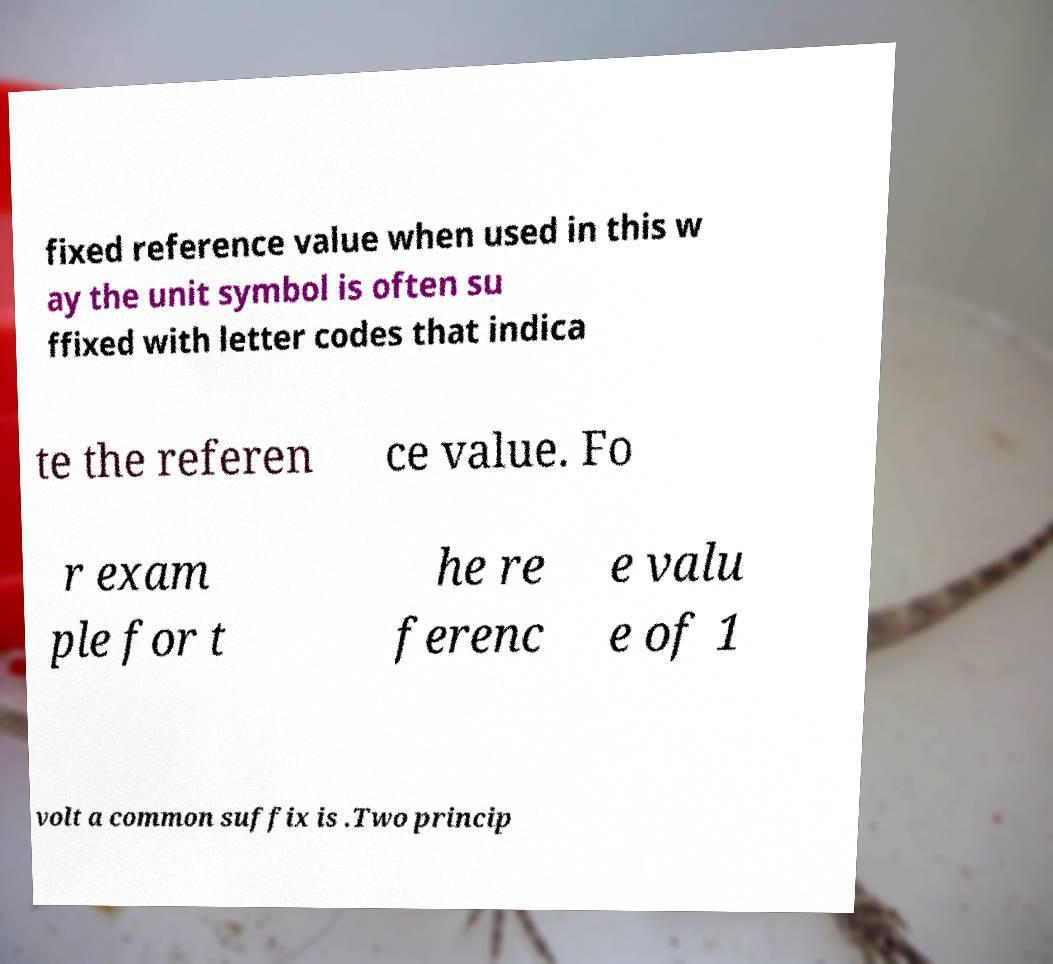Please identify and transcribe the text found in this image. fixed reference value when used in this w ay the unit symbol is often su ffixed with letter codes that indica te the referen ce value. Fo r exam ple for t he re ferenc e valu e of 1 volt a common suffix is .Two princip 